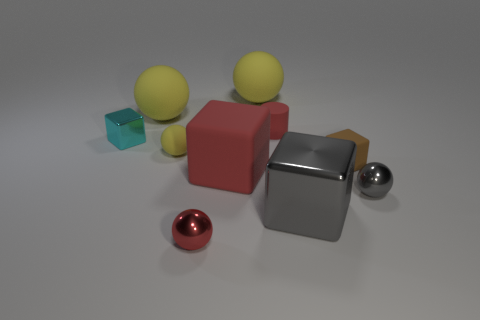Are there an equal number of yellow objects in front of the cyan object and small red spheres?
Offer a terse response. Yes. There is a gray shiny thing that is to the right of the brown matte cube; how big is it?
Offer a terse response. Small. How many big gray things are the same shape as the large red rubber thing?
Ensure brevity in your answer.  1. What is the tiny object that is both left of the large red matte object and in front of the brown matte block made of?
Provide a short and direct response. Metal. Are the cyan thing and the large gray object made of the same material?
Offer a terse response. Yes. How many large objects are there?
Your answer should be very brief. 4. There is a big block on the left side of the tiny red object behind the tiny metallic sphere that is in front of the small gray ball; what color is it?
Your answer should be compact. Red. Is the tiny rubber cube the same color as the big shiny cube?
Provide a short and direct response. No. How many big yellow matte things are right of the red metallic sphere and on the left side of the tiny yellow object?
Provide a short and direct response. 0. How many metal objects are either small blocks or cyan cubes?
Provide a succinct answer. 1. 